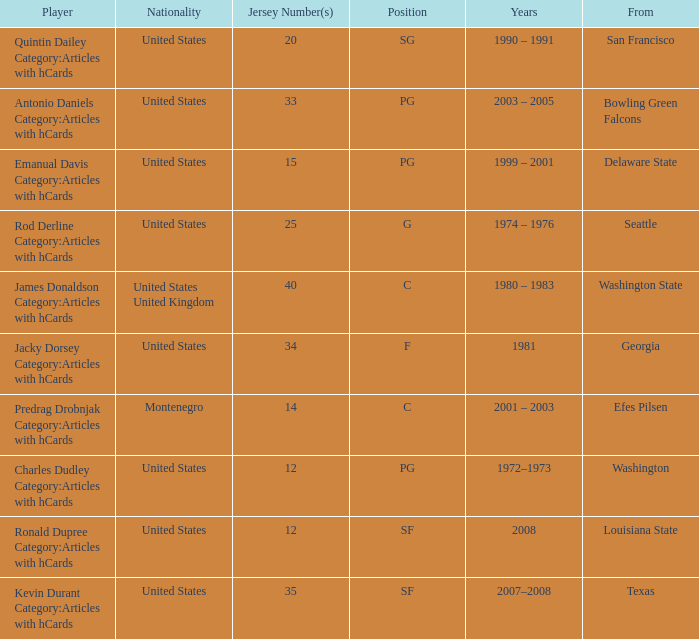What was the nationality of the players with a position of g? United States. 